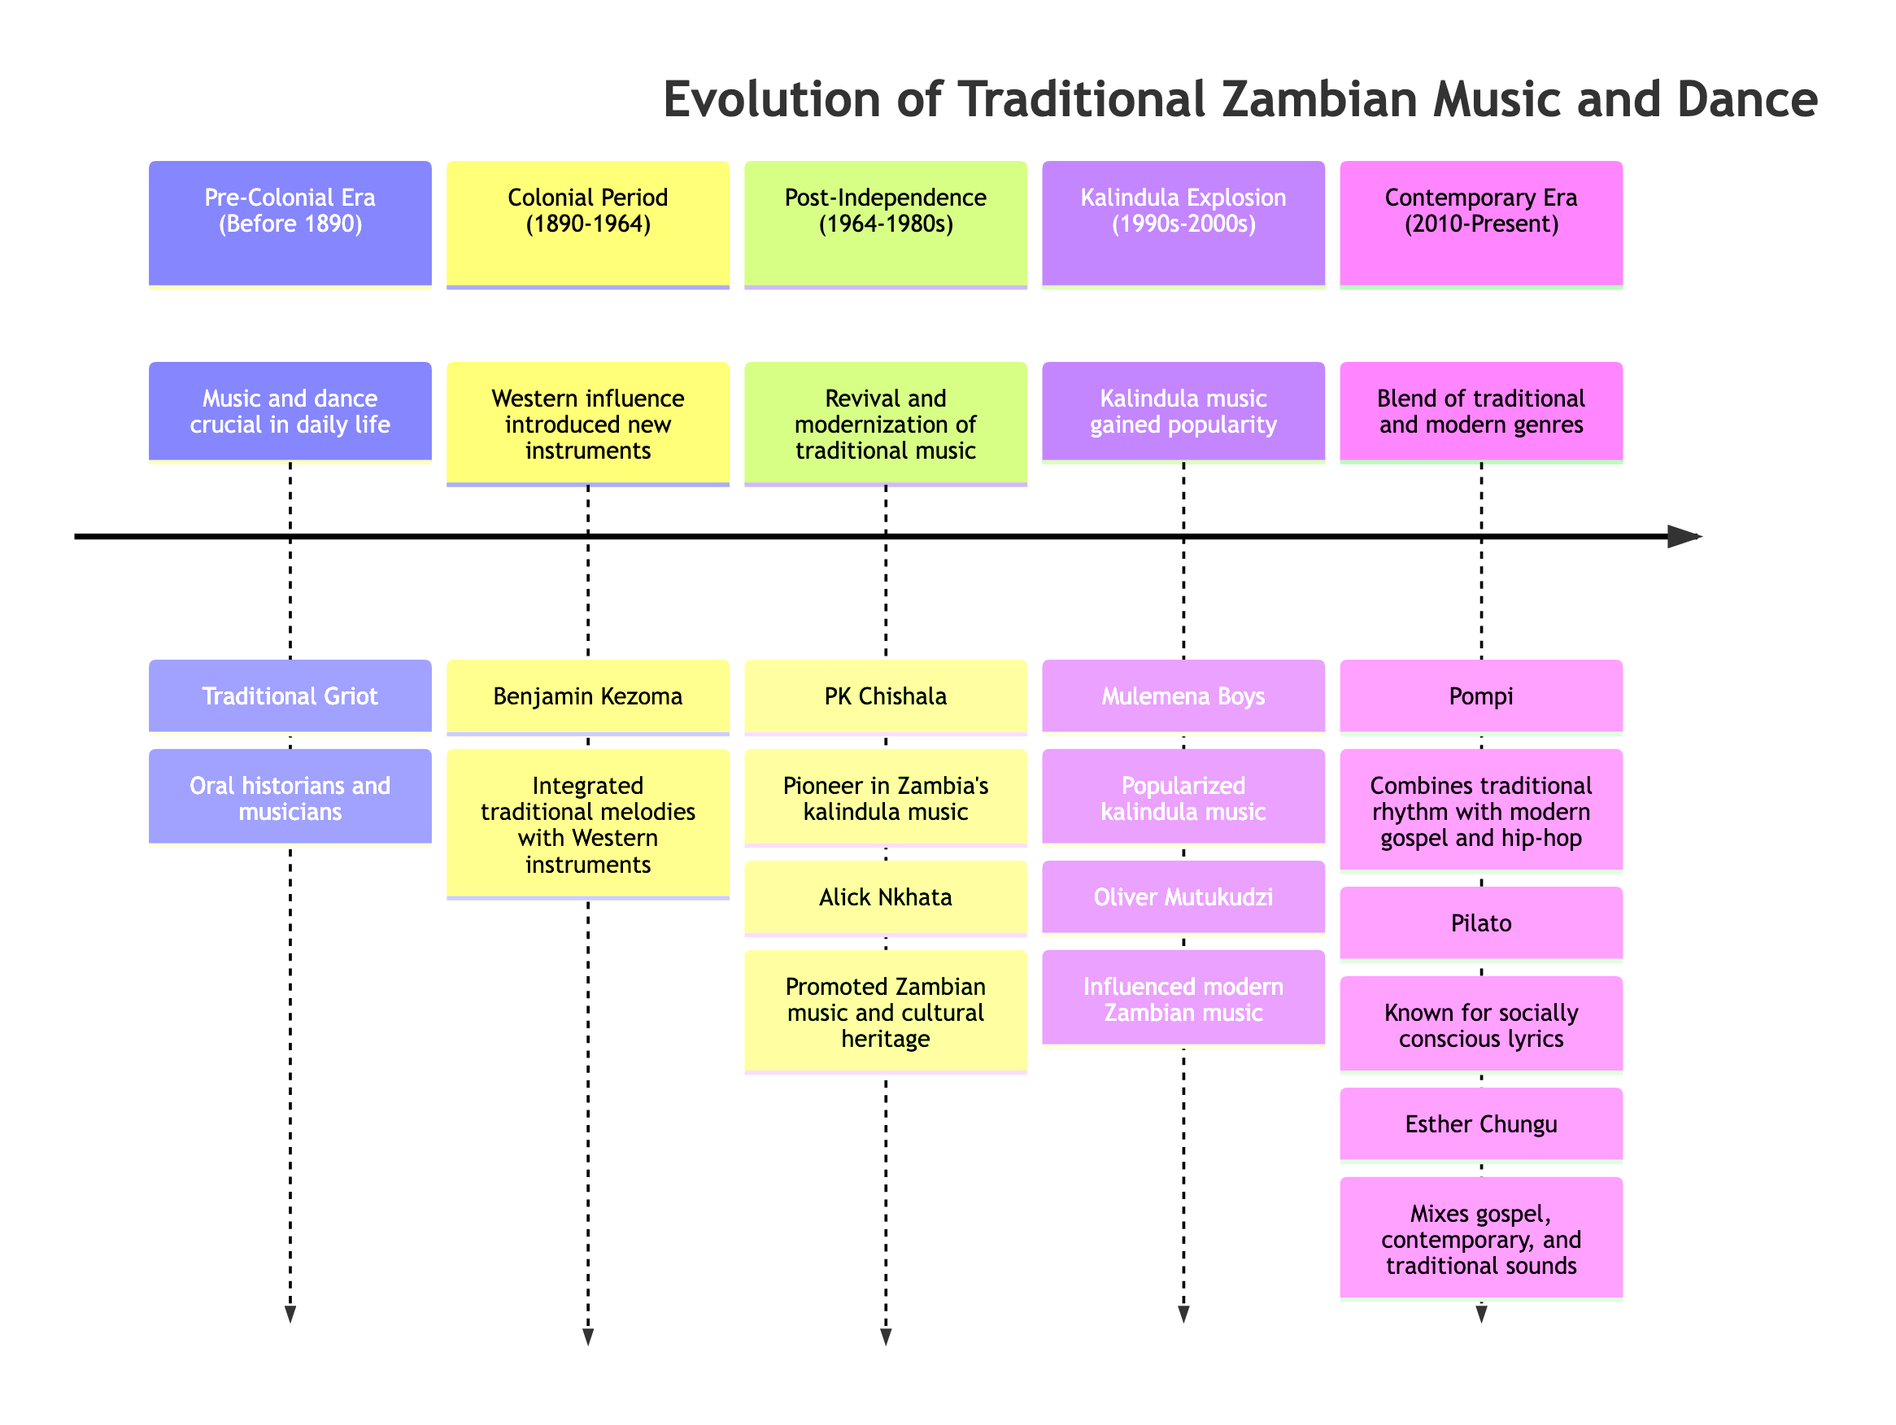What period focused on the revival and modernization of traditional music? The diagram indicates that the period known for the revival and modernization of traditional music is "Post-Independence (1964-1980s)" as per the associated description.
Answer: Post-Independence (1964-1980s) Who is known for integrating traditional melodies with Western instruments? Looking at the "Colonial Period (1890-1964)" section, Benjamin Kezoma is highlighted as the key artist known for this integration.
Answer: Benjamin Kezoma What major musical style surged in popularity during the 1990s-2000s? The diagram specifies that "Kalindula music" gained prominence in the section titled "Kalindula Explosion (1990s-2000s)."
Answer: Kalindula music Which artist is recognized as a pioneer in Zambia's kalindula music? Within the "Post-Independence (1964-1980s)" section, PK Chishala is identified as the pioneer in this genre.
Answer: PK Chishala How many key artists are mentioned from the Contemporary Era (2010-Present)? The diagram lists three key artists in the "Contemporary Era (2010-Present)" section: Pompi, Pilato, and Esther Chungu, totaling three artists.
Answer: 3 What instrument is commonly associated with Pre-Colonial Zambian music? The description for the "Pre-Colonial Era (Before 1890)" mentions traditional instruments like drums, rattles, and xylophones, specifically highlighting drums (ngoma).
Answer: Drums Which artist from the Kalindula Explosion period is known for popularizing kalindula music? The "Kalindula Explosion (1990s-2000s)" section lists Mulemena Boys as the artist who popularized this music style.
Answer: Mulemena Boys What was a significant change in music during the Colonial Period? The diagram shows that a significant change during the "Colonial Period (1890-1964)" was the introduction of Western instruments, specifically mentioning the guitar.
Answer: Introduction of Western instruments 